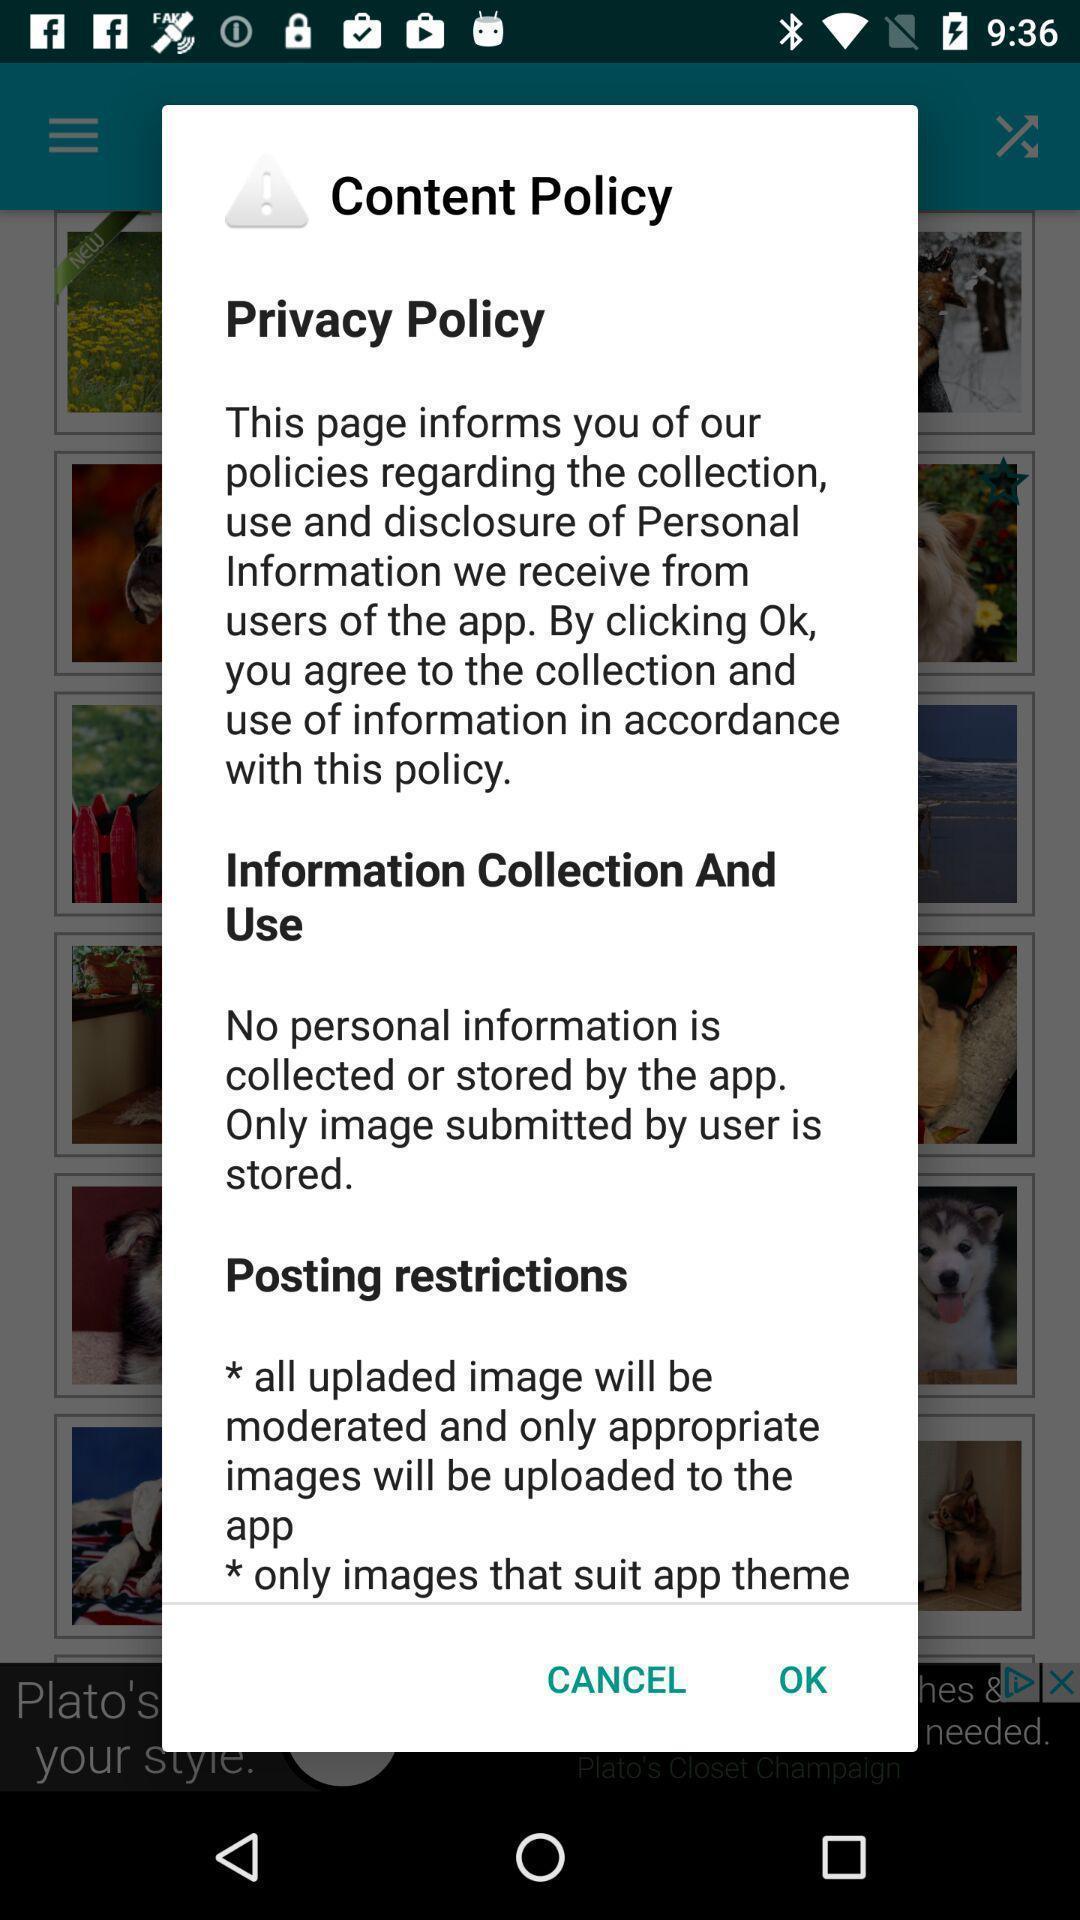Tell me what you see in this picture. Pop-up displaying privacy policy information to continue. 